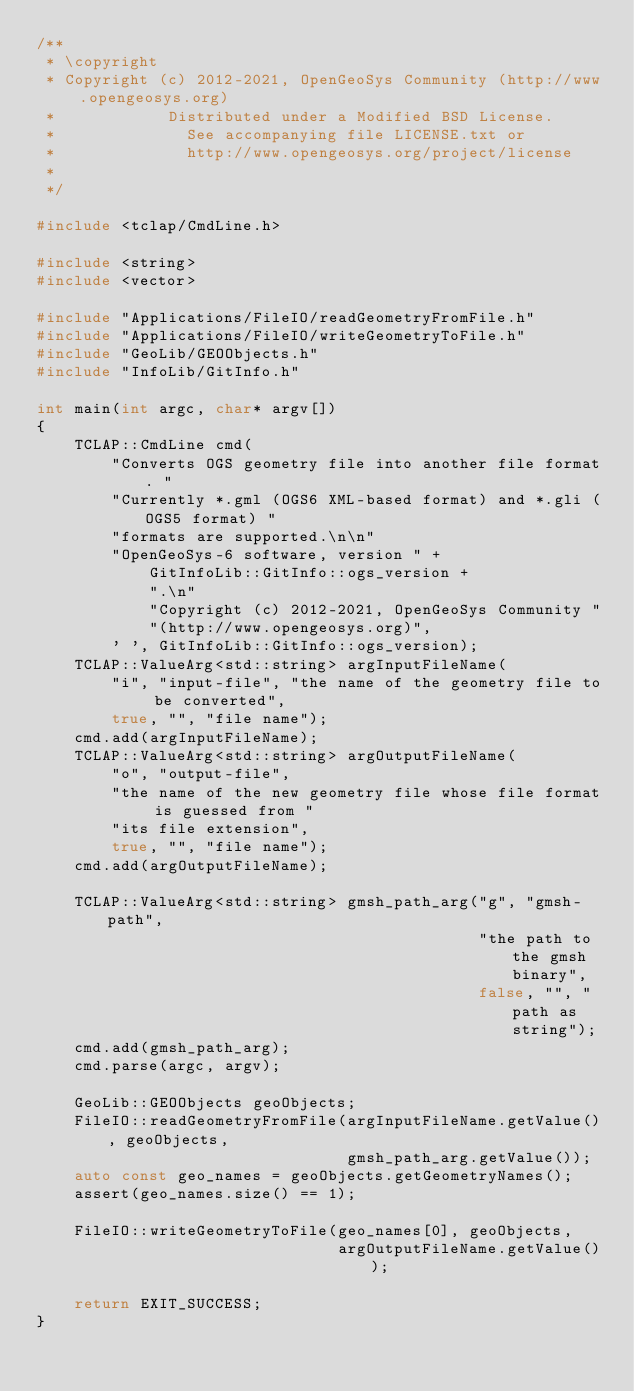<code> <loc_0><loc_0><loc_500><loc_500><_C++_>/**
 * \copyright
 * Copyright (c) 2012-2021, OpenGeoSys Community (http://www.opengeosys.org)
 *            Distributed under a Modified BSD License.
 *              See accompanying file LICENSE.txt or
 *              http://www.opengeosys.org/project/license
 *
 */

#include <tclap/CmdLine.h>

#include <string>
#include <vector>

#include "Applications/FileIO/readGeometryFromFile.h"
#include "Applications/FileIO/writeGeometryToFile.h"
#include "GeoLib/GEOObjects.h"
#include "InfoLib/GitInfo.h"

int main(int argc, char* argv[])
{
    TCLAP::CmdLine cmd(
        "Converts OGS geometry file into another file format. "
        "Currently *.gml (OGS6 XML-based format) and *.gli (OGS5 format) "
        "formats are supported.\n\n"
        "OpenGeoSys-6 software, version " +
            GitInfoLib::GitInfo::ogs_version +
            ".\n"
            "Copyright (c) 2012-2021, OpenGeoSys Community "
            "(http://www.opengeosys.org)",
        ' ', GitInfoLib::GitInfo::ogs_version);
    TCLAP::ValueArg<std::string> argInputFileName(
        "i", "input-file", "the name of the geometry file to be converted",
        true, "", "file name");
    cmd.add(argInputFileName);
    TCLAP::ValueArg<std::string> argOutputFileName(
        "o", "output-file",
        "the name of the new geometry file whose file format is guessed from "
        "its file extension",
        true, "", "file name");
    cmd.add(argOutputFileName);

    TCLAP::ValueArg<std::string> gmsh_path_arg("g", "gmsh-path",
                                               "the path to the gmsh binary",
                                               false, "", "path as string");
    cmd.add(gmsh_path_arg);
    cmd.parse(argc, argv);

    GeoLib::GEOObjects geoObjects;
    FileIO::readGeometryFromFile(argInputFileName.getValue(), geoObjects,
                                 gmsh_path_arg.getValue());
    auto const geo_names = geoObjects.getGeometryNames();
    assert(geo_names.size() == 1);

    FileIO::writeGeometryToFile(geo_names[0], geoObjects,
                                argOutputFileName.getValue());

    return EXIT_SUCCESS;
}
</code> 